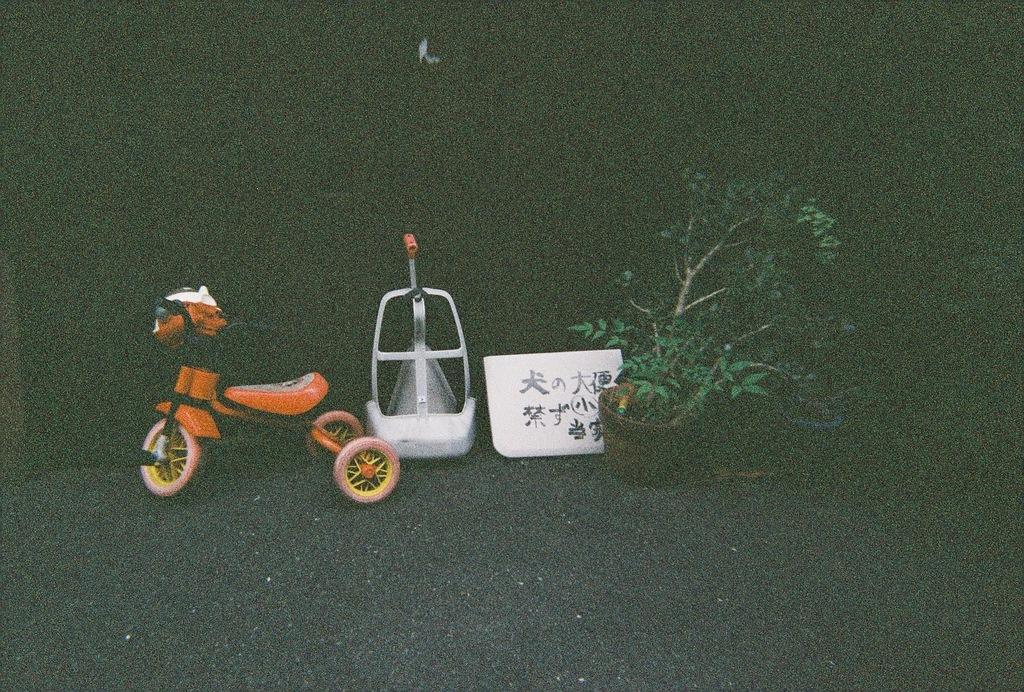Please provide a concise description of this image. In this image we can see the tricycle, potted plant, board with text and white color object and at the back we can see the dark background. 